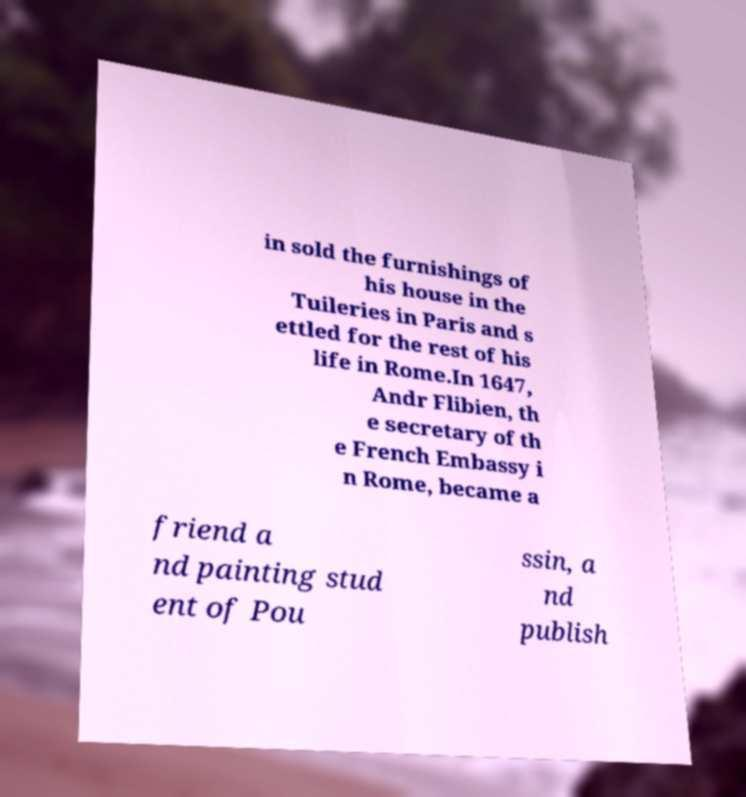Please read and relay the text visible in this image. What does it say? in sold the furnishings of his house in the Tuileries in Paris and s ettled for the rest of his life in Rome.In 1647, Andr Flibien, th e secretary of th e French Embassy i n Rome, became a friend a nd painting stud ent of Pou ssin, a nd publish 